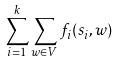Convert formula to latex. <formula><loc_0><loc_0><loc_500><loc_500>\sum _ { i = 1 } ^ { k } \sum _ { w \in V } f _ { i } ( s _ { i } , w )</formula> 